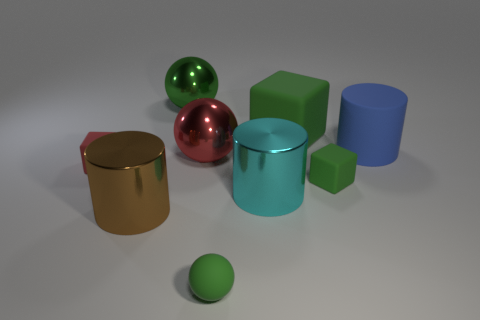Subtract all large metal cylinders. How many cylinders are left? 1 Add 1 blue matte things. How many objects exist? 10 Subtract all green spheres. How many spheres are left? 1 Subtract all cylinders. How many objects are left? 6 Subtract 2 cubes. How many cubes are left? 1 Subtract all tiny green rubber blocks. Subtract all red objects. How many objects are left? 6 Add 2 cubes. How many cubes are left? 5 Add 7 tiny red rubber blocks. How many tiny red rubber blocks exist? 8 Subtract 0 brown spheres. How many objects are left? 9 Subtract all cyan blocks. Subtract all yellow spheres. How many blocks are left? 3 